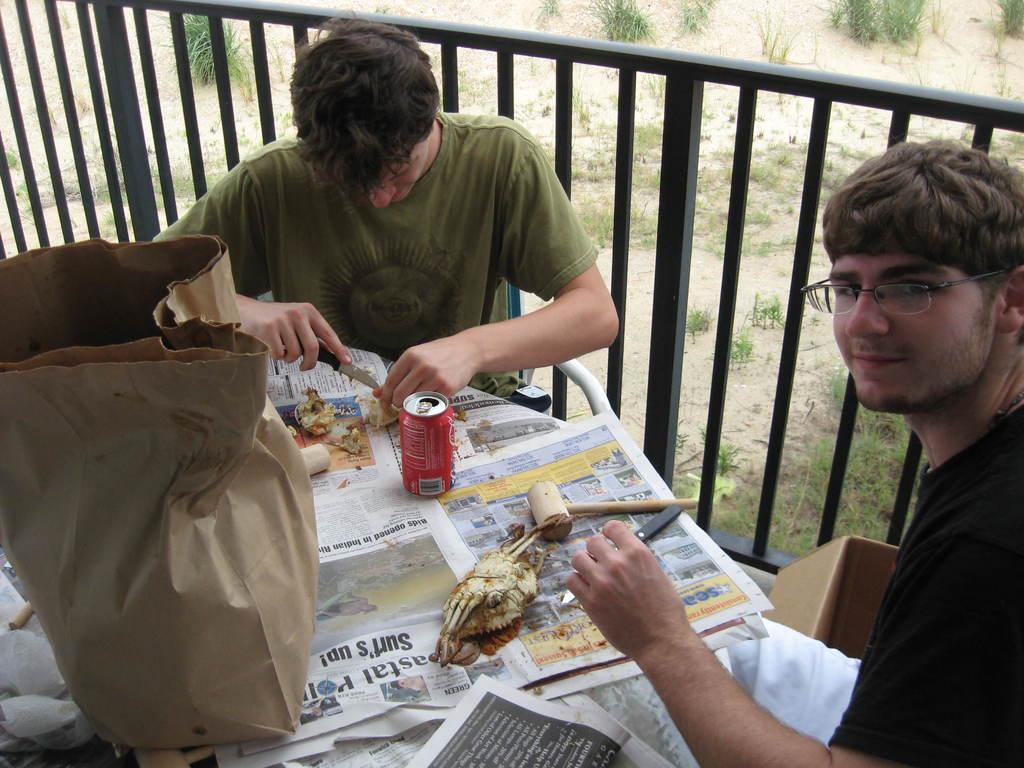Can you describe this image briefly? This 2 persons are sitting on a chair. In-front of this 2 persons there is a table. On a table there is a bag, newspaper, tin and hammer. This person is holding a knife. This is fence in black color. 